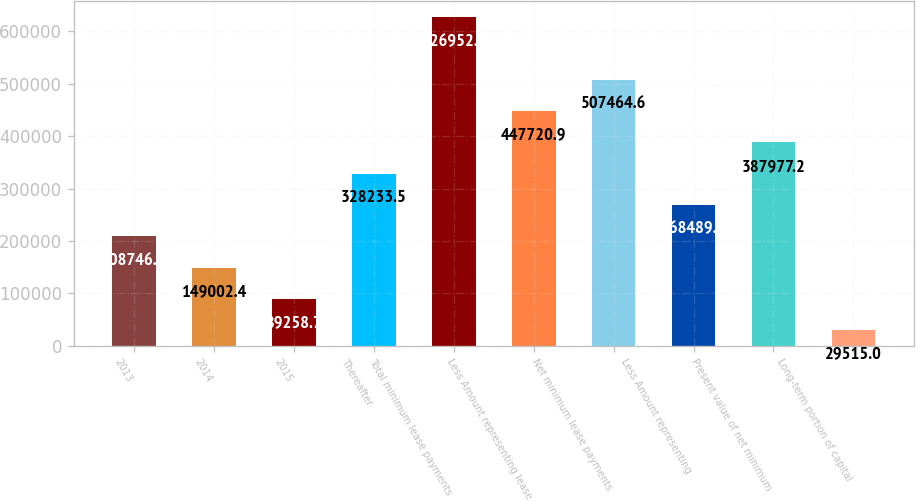Convert chart. <chart><loc_0><loc_0><loc_500><loc_500><bar_chart><fcel>2013<fcel>2014<fcel>2015<fcel>Thereafter<fcel>Total minimum lease payments<fcel>Less Amount representing lease<fcel>Net minimum lease payments<fcel>Less Amount representing<fcel>Present value of net minimum<fcel>Long-term portion of capital<nl><fcel>208746<fcel>149002<fcel>89258.7<fcel>328234<fcel>626952<fcel>447721<fcel>507465<fcel>268490<fcel>387977<fcel>29515<nl></chart> 